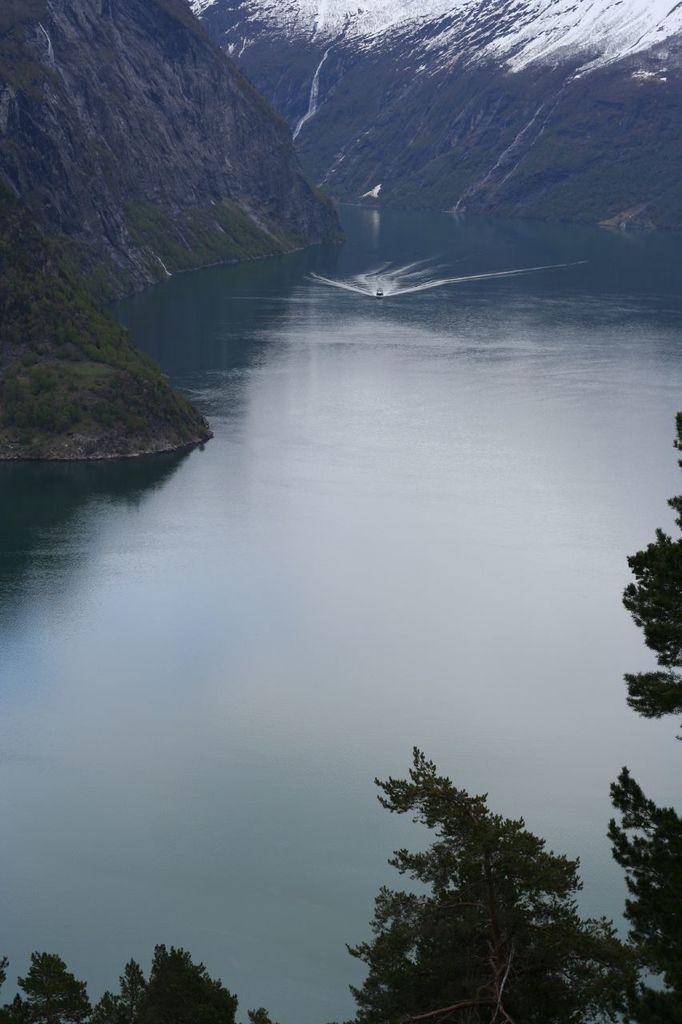Please provide a concise description of this image. There are branches of trees at the bottom of this image, and there is a sea in the middle of this image, and there is a mountain the background. 